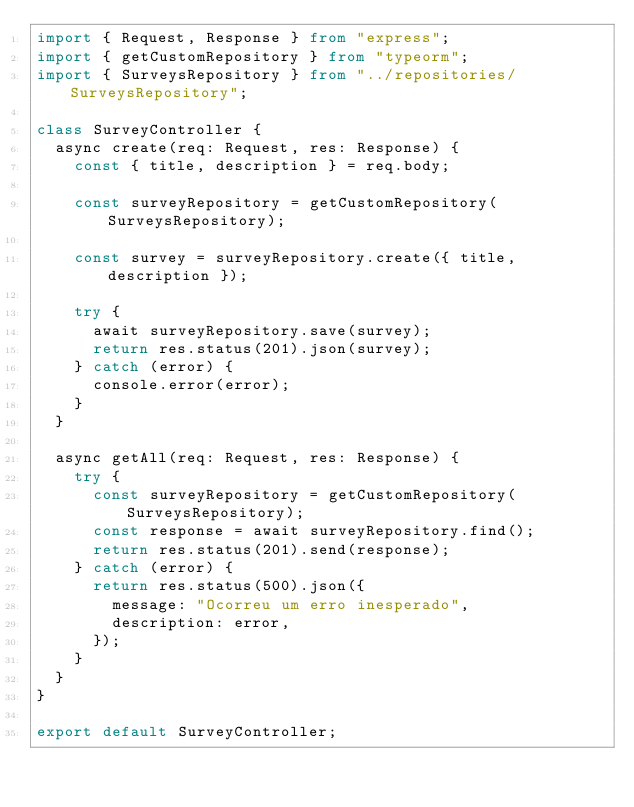Convert code to text. <code><loc_0><loc_0><loc_500><loc_500><_TypeScript_>import { Request, Response } from "express";
import { getCustomRepository } from "typeorm";
import { SurveysRepository } from "../repositories/SurveysRepository";

class SurveyController {
  async create(req: Request, res: Response) {
    const { title, description } = req.body;

    const surveyRepository = getCustomRepository(SurveysRepository);

    const survey = surveyRepository.create({ title, description });

    try {
      await surveyRepository.save(survey);
      return res.status(201).json(survey);
    } catch (error) {
      console.error(error);
    }
  }

  async getAll(req: Request, res: Response) {
    try {
      const surveyRepository = getCustomRepository(SurveysRepository);
      const response = await surveyRepository.find();
      return res.status(201).send(response);
    } catch (error) {
      return res.status(500).json({
        message: "Ocorreu um erro inesperado",
        description: error,
      });
    }
  }
}

export default SurveyController;
</code> 